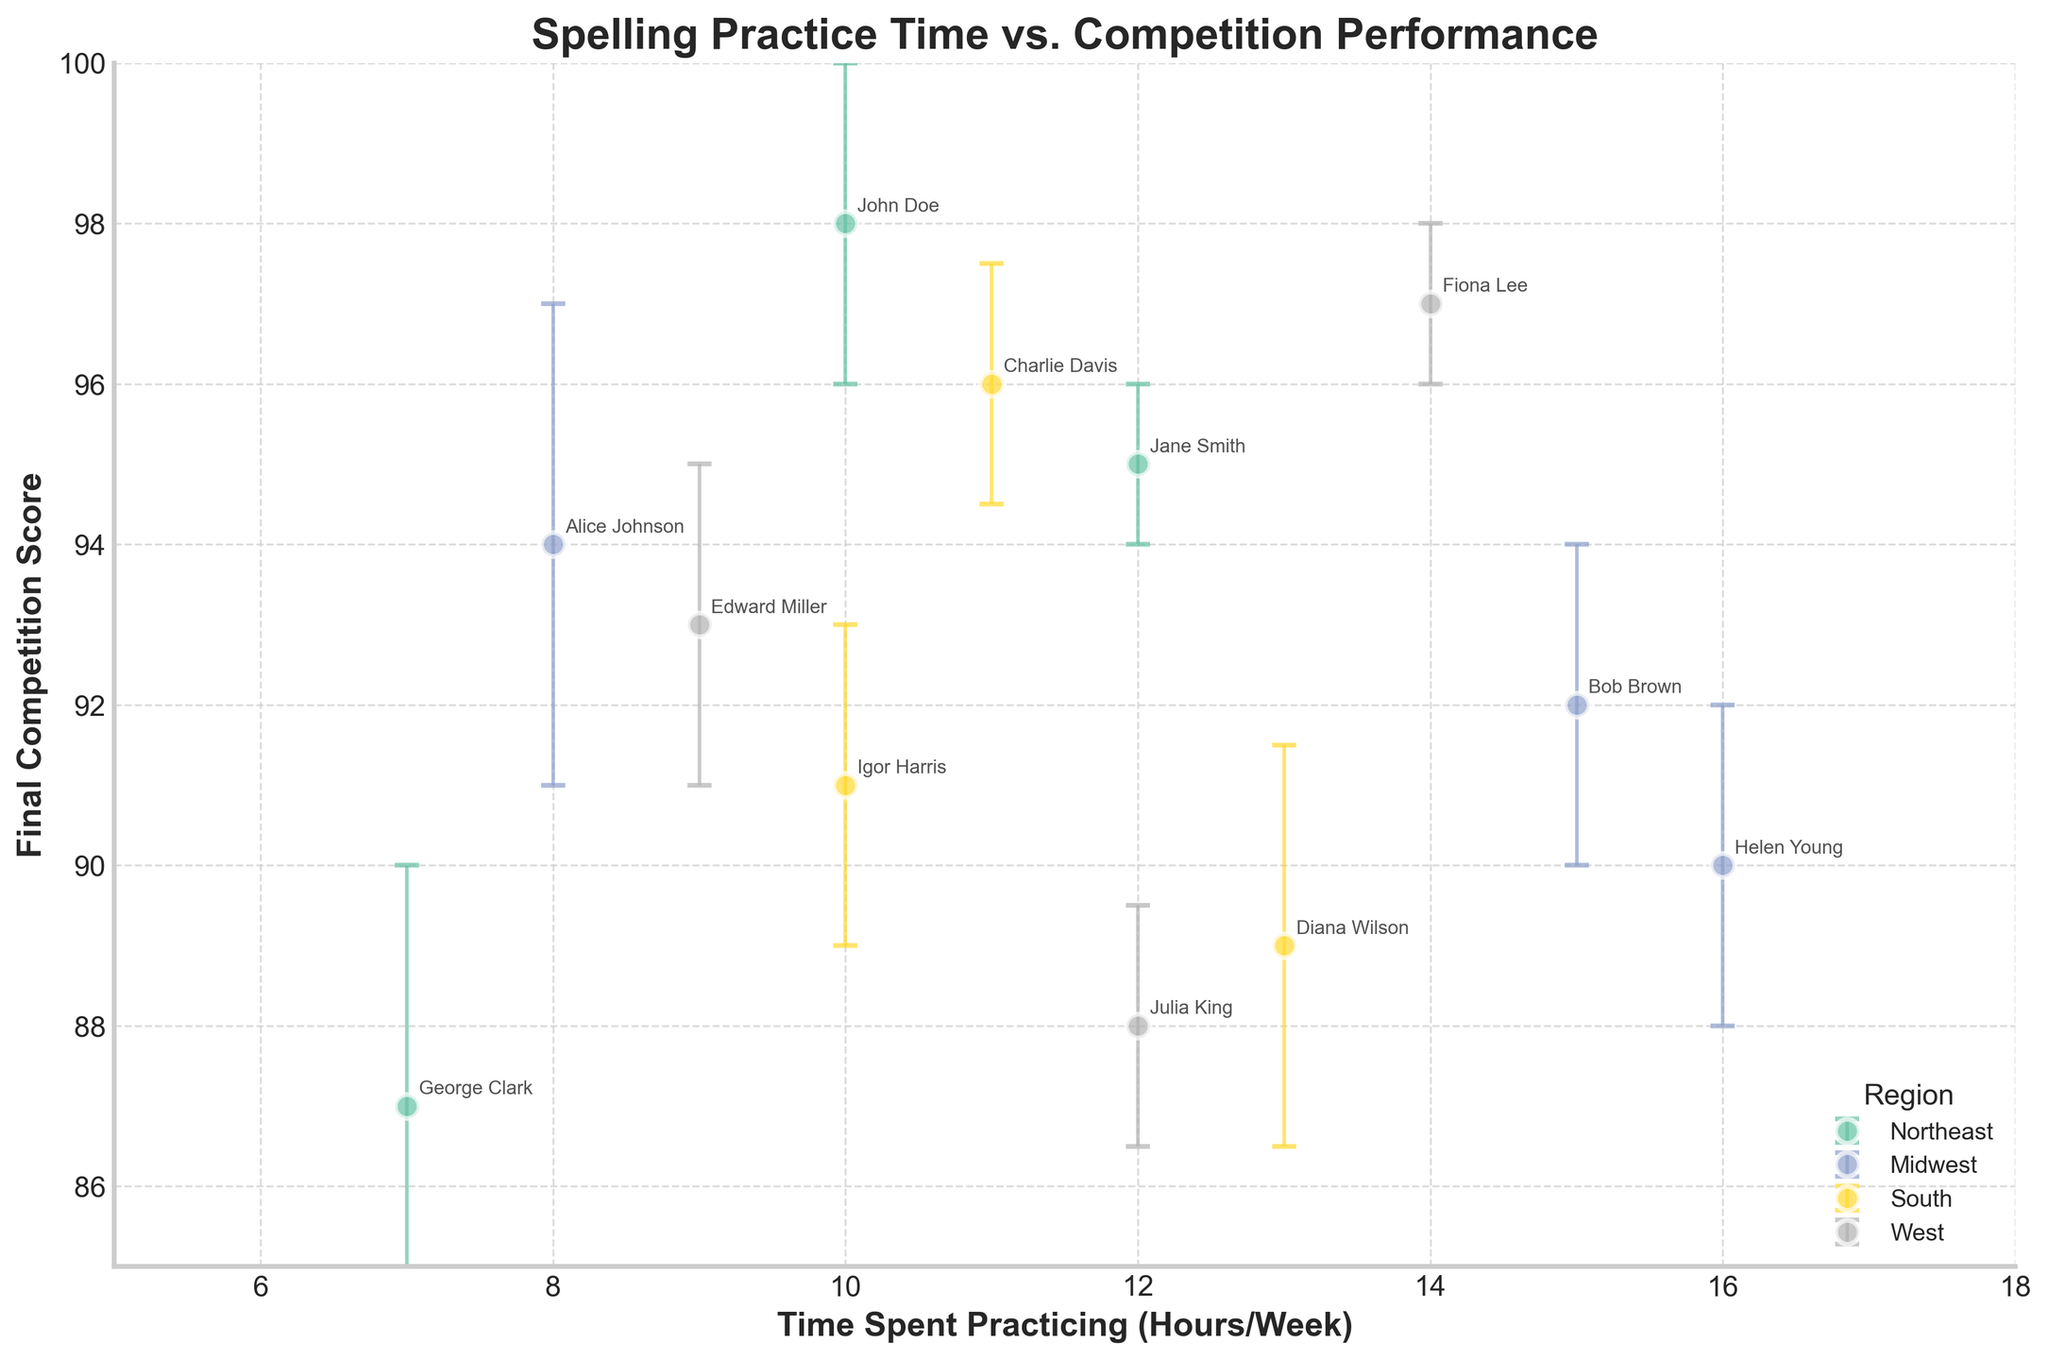What's the title of the figure? The title of the figure is displayed prominently at the top. You can read it directly from there.
Answer: Spelling Practice Time vs. Competition Performance What does the x-axis represent? The label of the x-axis describes what it represents. Look at the text directly below the x-axis.
Answer: Time Spent Practicing (Hours/Week) How many data points represent the Northeast region? Identify points marked in the same color and labeled as "Northeast." Count these points in the scatter plot. There are three labeled points: John Doe, Jane Smith, and George Clark.
Answer: 3 Which speller practiced the most hours per week? Look for the data point that is farthest to the right on the x-axis because it represents the highest value of time spent practicing per week. According to the figure, Helen Young practiced for 16 hours per week.
Answer: Helen Young Which region has the highest average final competition score? To find the region with the highest average score, sum the final competition scores for each data point within each region, then divide by the number of data points for that region. Compare the averages. The Northeast region has final scores 98, 95, and 87, the Midwest region has 94, 92, and 90, the South region has 96, 89, and 91, and the West region has 93, 97, and 88. The averages are 93.33, 92, 92, and 92.67 respectively.
Answer: West Which speller has the largest error bar? Look for the data point with the longest vertical error bar. According to the figure, Alice Johnson from the Midwest has the longest error bar at 3.
Answer: Alice Johnson Does the West region show any data point with a final competition score below 90? Check the data points labeled as "West" and see if any fall below the score of 90 on the y-axis. According to the figure, Julia King from the West has a final competition score of 88.
Answer: Yes What is the difference in final competition score between the top scoring Northeast and West spellers? Identify the highest final competition scores for the Northeast and West regions. The highest for the Northeast is John Doe with 98, and for the West is Fiona Lee with 97. The difference is 98 - 97.
Answer: 1 Which region has the greatest variability in final competition scores? Variability can generally be indicated by the range of error bars. Identify the region with the longest average error bars. This can be calculated by averaging the error bars in each region and comparing. The Midwest region generally has higher error bars (2 and 3 compared to smaller values).
Answer: Midwest 